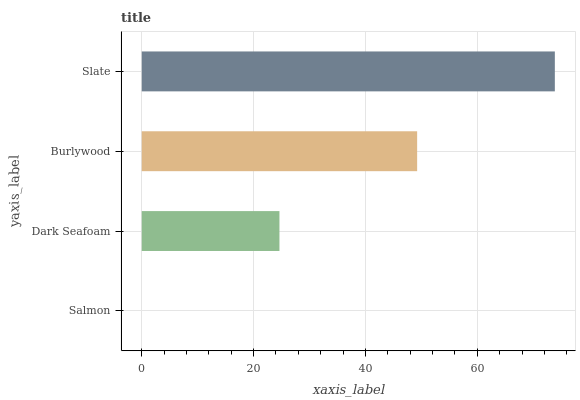Is Salmon the minimum?
Answer yes or no. Yes. Is Slate the maximum?
Answer yes or no. Yes. Is Dark Seafoam the minimum?
Answer yes or no. No. Is Dark Seafoam the maximum?
Answer yes or no. No. Is Dark Seafoam greater than Salmon?
Answer yes or no. Yes. Is Salmon less than Dark Seafoam?
Answer yes or no. Yes. Is Salmon greater than Dark Seafoam?
Answer yes or no. No. Is Dark Seafoam less than Salmon?
Answer yes or no. No. Is Burlywood the high median?
Answer yes or no. Yes. Is Dark Seafoam the low median?
Answer yes or no. Yes. Is Slate the high median?
Answer yes or no. No. Is Salmon the low median?
Answer yes or no. No. 